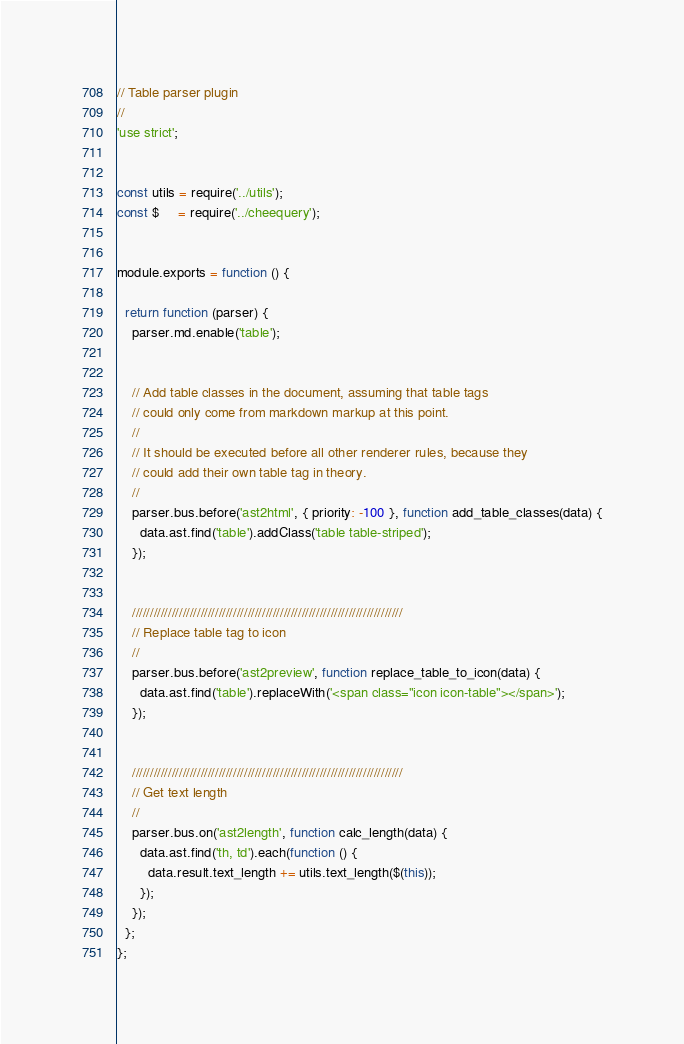Convert code to text. <code><loc_0><loc_0><loc_500><loc_500><_JavaScript_>// Table parser plugin
//
'use strict';


const utils = require('../utils');
const $     = require('../cheequery');


module.exports = function () {

  return function (parser) {
    parser.md.enable('table');


    // Add table classes in the document, assuming that table tags
    // could only come from markdown markup at this point.
    //
    // It should be executed before all other renderer rules, because they
    // could add their own table tag in theory.
    //
    parser.bus.before('ast2html', { priority: -100 }, function add_table_classes(data) {
      data.ast.find('table').addClass('table table-striped');
    });


    ///////////////////////////////////////////////////////////////////////////
    // Replace table tag to icon
    //
    parser.bus.before('ast2preview', function replace_table_to_icon(data) {
      data.ast.find('table').replaceWith('<span class="icon icon-table"></span>');
    });


    ///////////////////////////////////////////////////////////////////////////
    // Get text length
    //
    parser.bus.on('ast2length', function calc_length(data) {
      data.ast.find('th, td').each(function () {
        data.result.text_length += utils.text_length($(this));
      });
    });
  };
};
</code> 